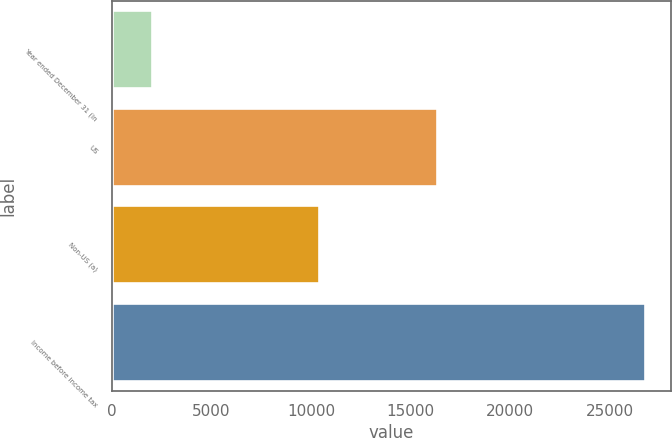Convert chart to OTSL. <chart><loc_0><loc_0><loc_500><loc_500><bar_chart><fcel>Year ended December 31 (in<fcel>US<fcel>Non-US (a)<fcel>Income before income tax<nl><fcel>2011<fcel>16336<fcel>10413<fcel>26749<nl></chart> 